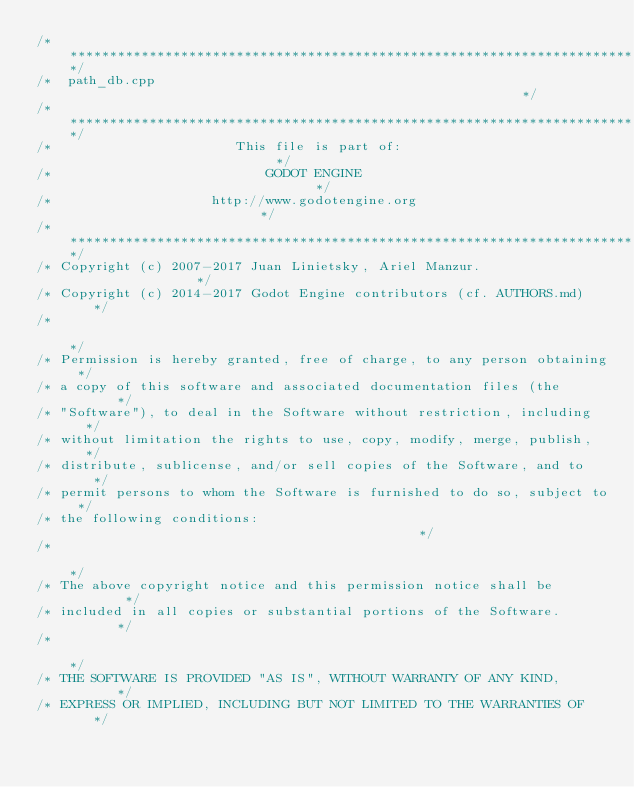Convert code to text. <code><loc_0><loc_0><loc_500><loc_500><_C++_>/*************************************************************************/
/*  path_db.cpp                                                          */
/*************************************************************************/
/*                       This file is part of:                           */
/*                           GODOT ENGINE                                */
/*                    http://www.godotengine.org                         */
/*************************************************************************/
/* Copyright (c) 2007-2017 Juan Linietsky, Ariel Manzur.                 */
/* Copyright (c) 2014-2017 Godot Engine contributors (cf. AUTHORS.md)    */
/*                                                                       */
/* Permission is hereby granted, free of charge, to any person obtaining */
/* a copy of this software and associated documentation files (the       */
/* "Software"), to deal in the Software without restriction, including   */
/* without limitation the rights to use, copy, modify, merge, publish,   */
/* distribute, sublicense, and/or sell copies of the Software, and to    */
/* permit persons to whom the Software is furnished to do so, subject to */
/* the following conditions:                                             */
/*                                                                       */
/* The above copyright notice and this permission notice shall be        */
/* included in all copies or substantial portions of the Software.       */
/*                                                                       */
/* THE SOFTWARE IS PROVIDED "AS IS", WITHOUT WARRANTY OF ANY KIND,       */
/* EXPRESS OR IMPLIED, INCLUDING BUT NOT LIMITED TO THE WARRANTIES OF    */</code> 